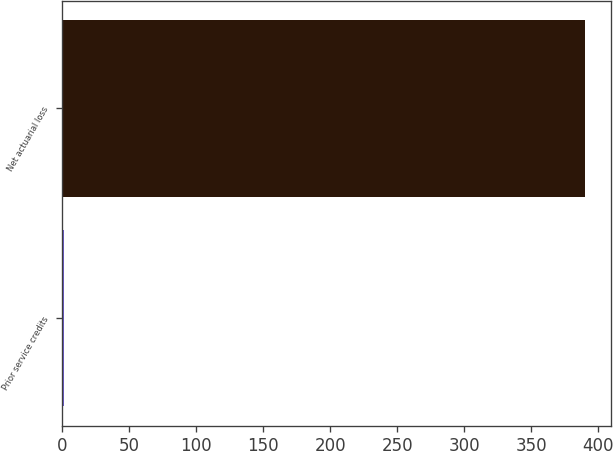Convert chart to OTSL. <chart><loc_0><loc_0><loc_500><loc_500><bar_chart><fcel>Prior service credits<fcel>Net actuarial loss<nl><fcel>1<fcel>390<nl></chart> 